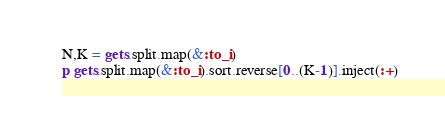<code> <loc_0><loc_0><loc_500><loc_500><_Ruby_>N,K = gets.split.map(&:to_i)
p gets.split.map(&:to_i).sort.reverse[0..(K-1)].inject(:+)</code> 